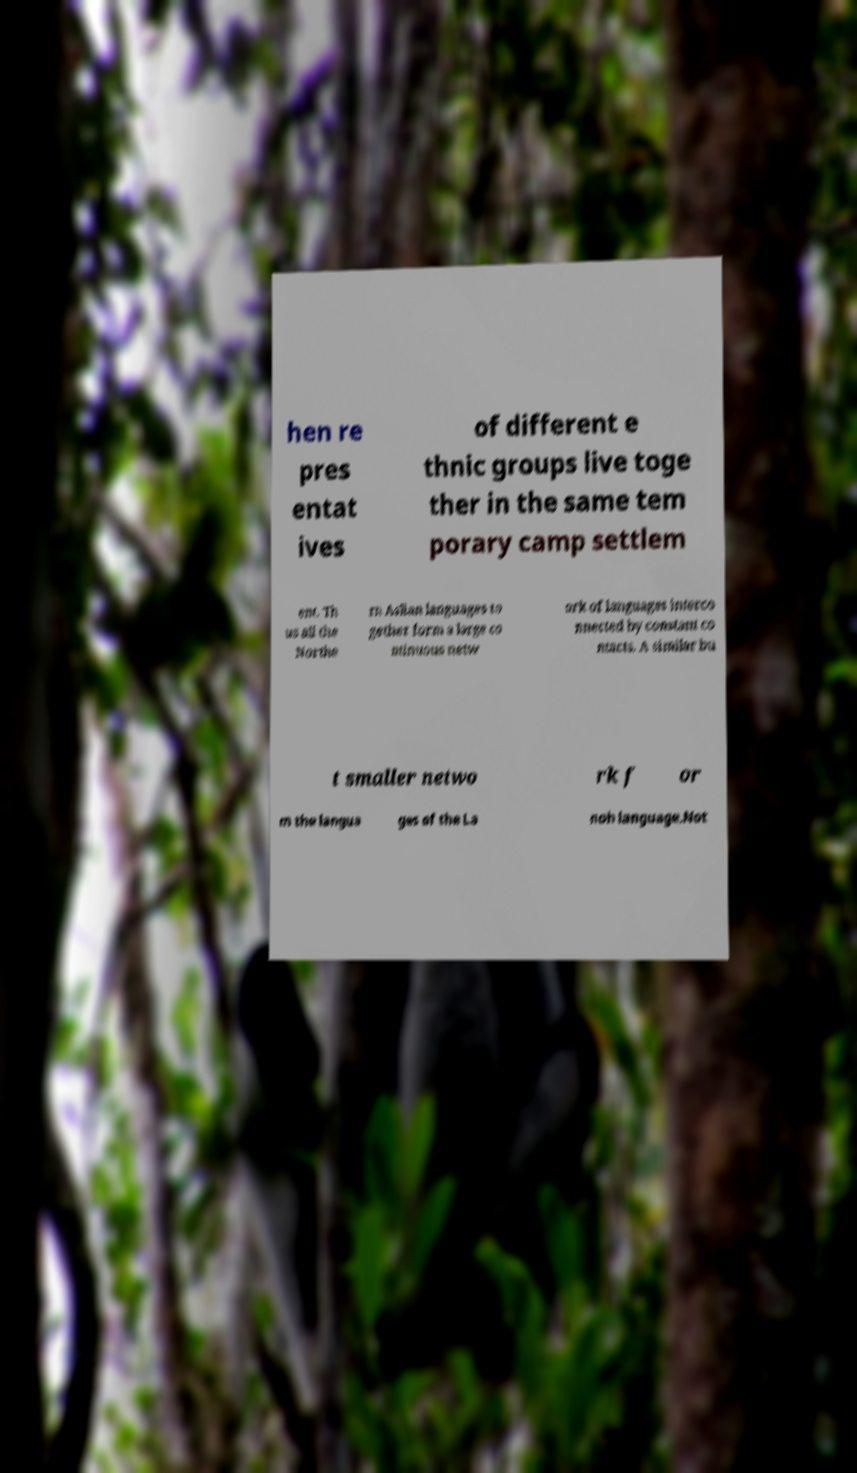I need the written content from this picture converted into text. Can you do that? hen re pres entat ives of different e thnic groups live toge ther in the same tem porary camp settlem ent. Th us all the Northe rn Aslian languages to gether form a large co ntinuous netw ork of languages interco nnected by constant co ntacts. A similar bu t smaller netwo rk f or m the langua ges of the La noh language.Not 